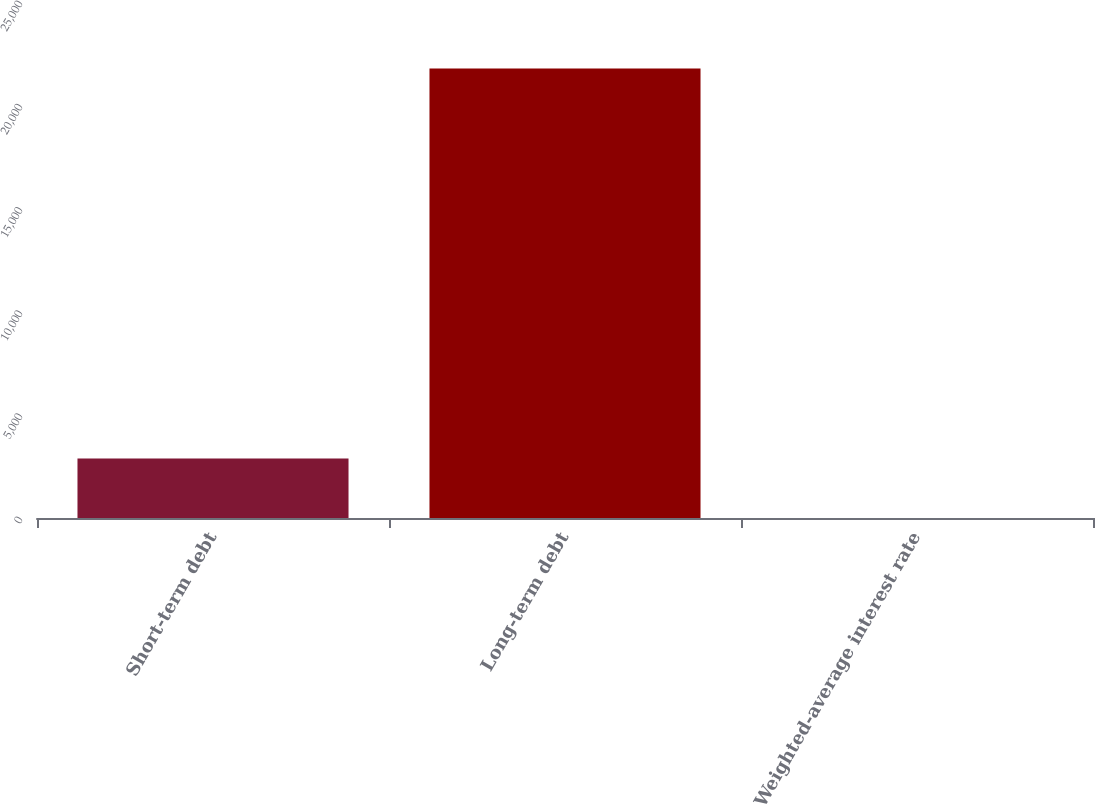Convert chart to OTSL. <chart><loc_0><loc_0><loc_500><loc_500><bar_chart><fcel>Short-term debt<fcel>Long-term debt<fcel>Weighted-average interest rate<nl><fcel>2885<fcel>21780<fcel>3.4<nl></chart> 